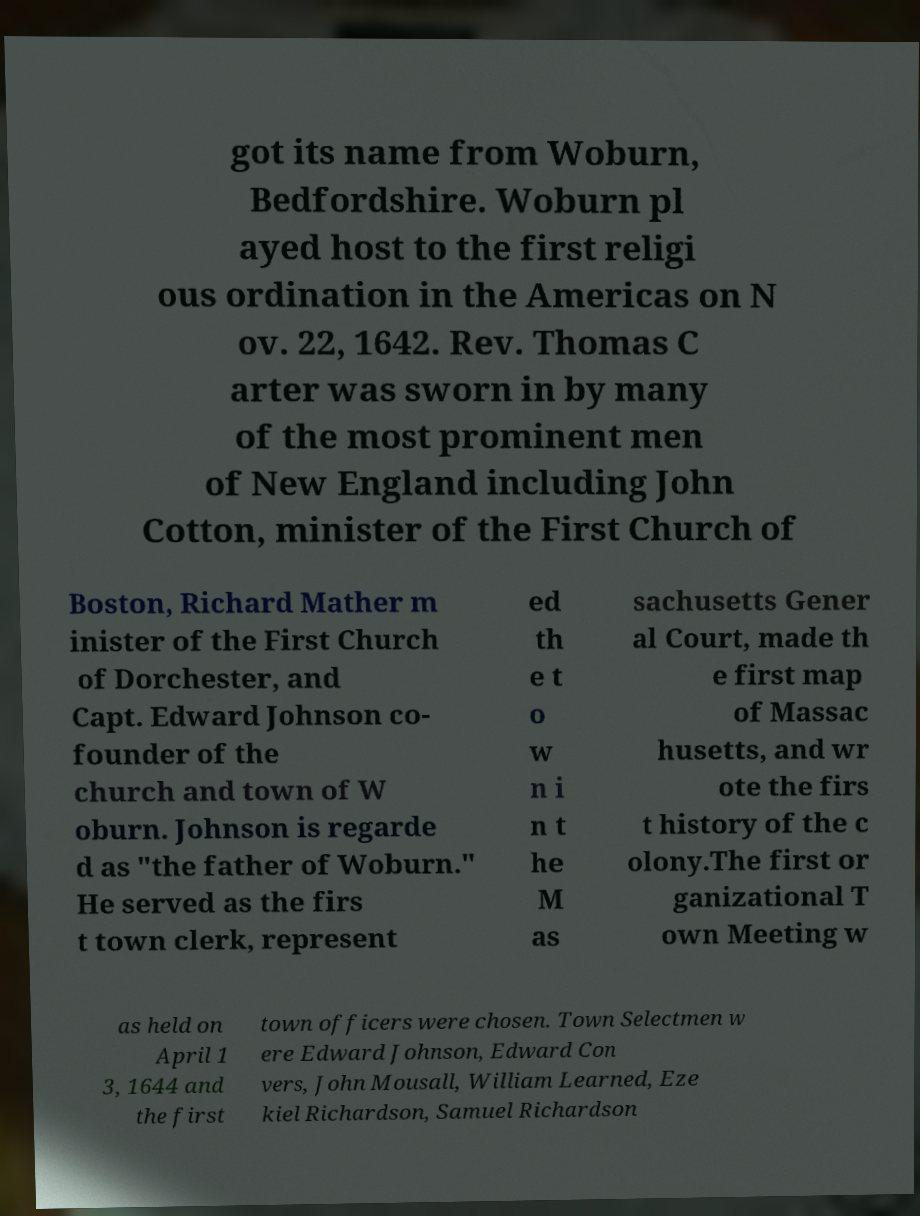Could you assist in decoding the text presented in this image and type it out clearly? got its name from Woburn, Bedfordshire. Woburn pl ayed host to the first religi ous ordination in the Americas on N ov. 22, 1642. Rev. Thomas C arter was sworn in by many of the most prominent men of New England including John Cotton, minister of the First Church of Boston, Richard Mather m inister of the First Church of Dorchester, and Capt. Edward Johnson co- founder of the church and town of W oburn. Johnson is regarde d as "the father of Woburn." He served as the firs t town clerk, represent ed th e t o w n i n t he M as sachusetts Gener al Court, made th e first map of Massac husetts, and wr ote the firs t history of the c olony.The first or ganizational T own Meeting w as held on April 1 3, 1644 and the first town officers were chosen. Town Selectmen w ere Edward Johnson, Edward Con vers, John Mousall, William Learned, Eze kiel Richardson, Samuel Richardson 